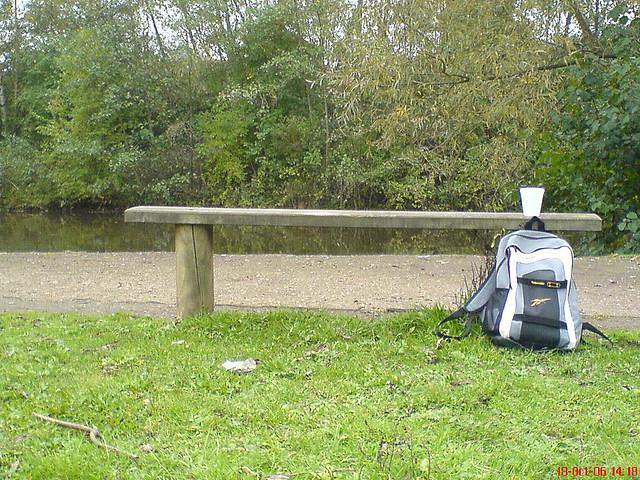Is the path paved?
Quick response, please. No. What is leaning in the bench?
Be succinct. Backpack. What is on top of the bench?
Quick response, please. Cup. 